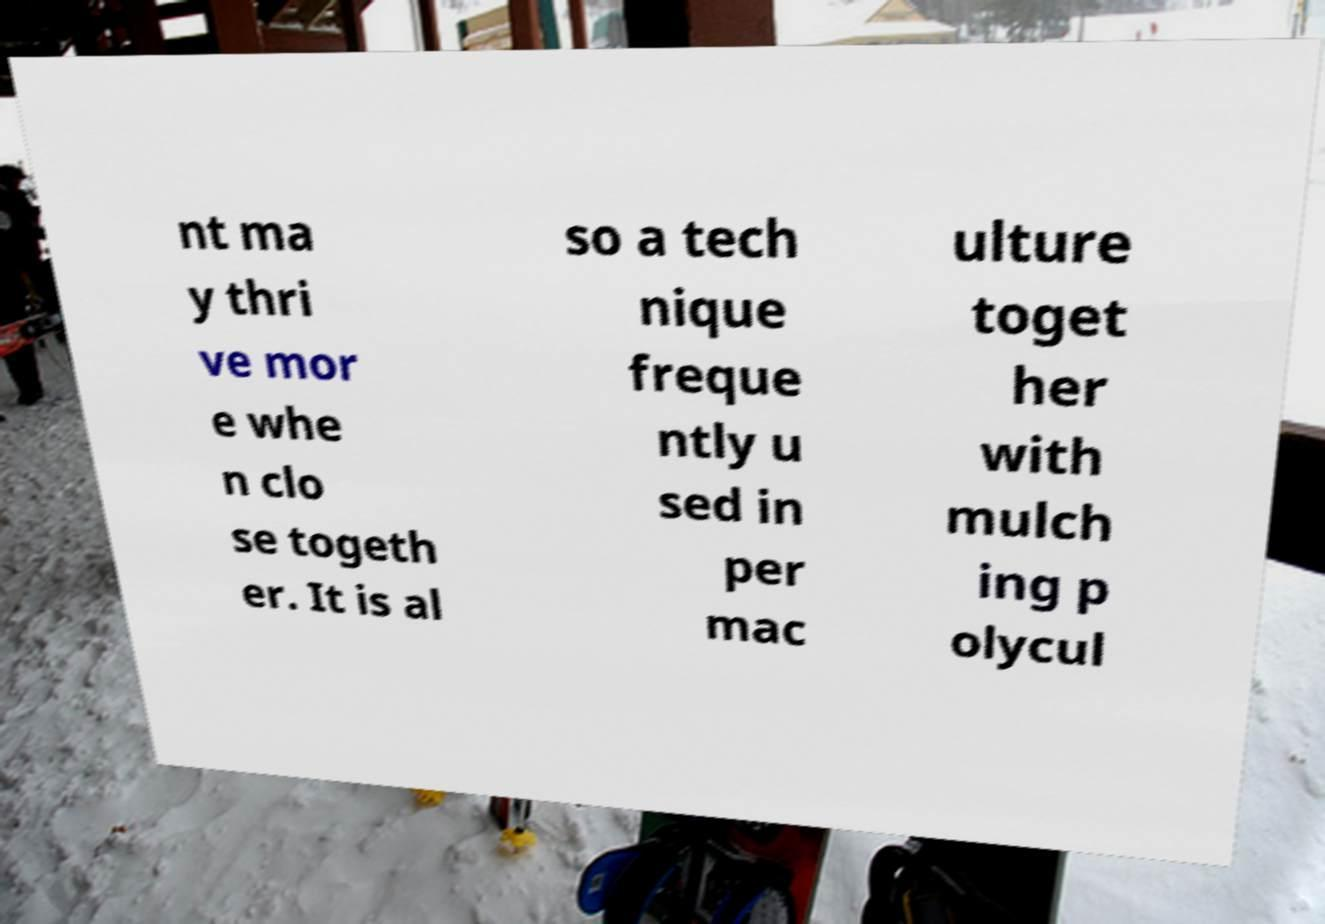There's text embedded in this image that I need extracted. Can you transcribe it verbatim? nt ma y thri ve mor e whe n clo se togeth er. It is al so a tech nique freque ntly u sed in per mac ulture toget her with mulch ing p olycul 